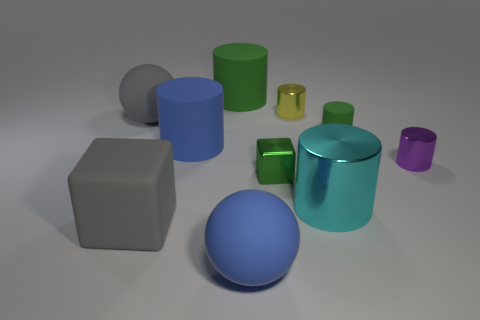Subtract all small green cylinders. How many cylinders are left? 5 Subtract all purple blocks. How many green cylinders are left? 2 Subtract 2 cylinders. How many cylinders are left? 4 Subtract all purple cylinders. How many cylinders are left? 5 Subtract all gray spheres. Subtract all green cylinders. How many spheres are left? 1 Add 6 large yellow balls. How many large yellow balls exist? 6 Subtract 1 gray cubes. How many objects are left? 9 Subtract all cylinders. How many objects are left? 4 Subtract all small metal spheres. Subtract all large blue spheres. How many objects are left? 9 Add 7 big rubber cubes. How many big rubber cubes are left? 8 